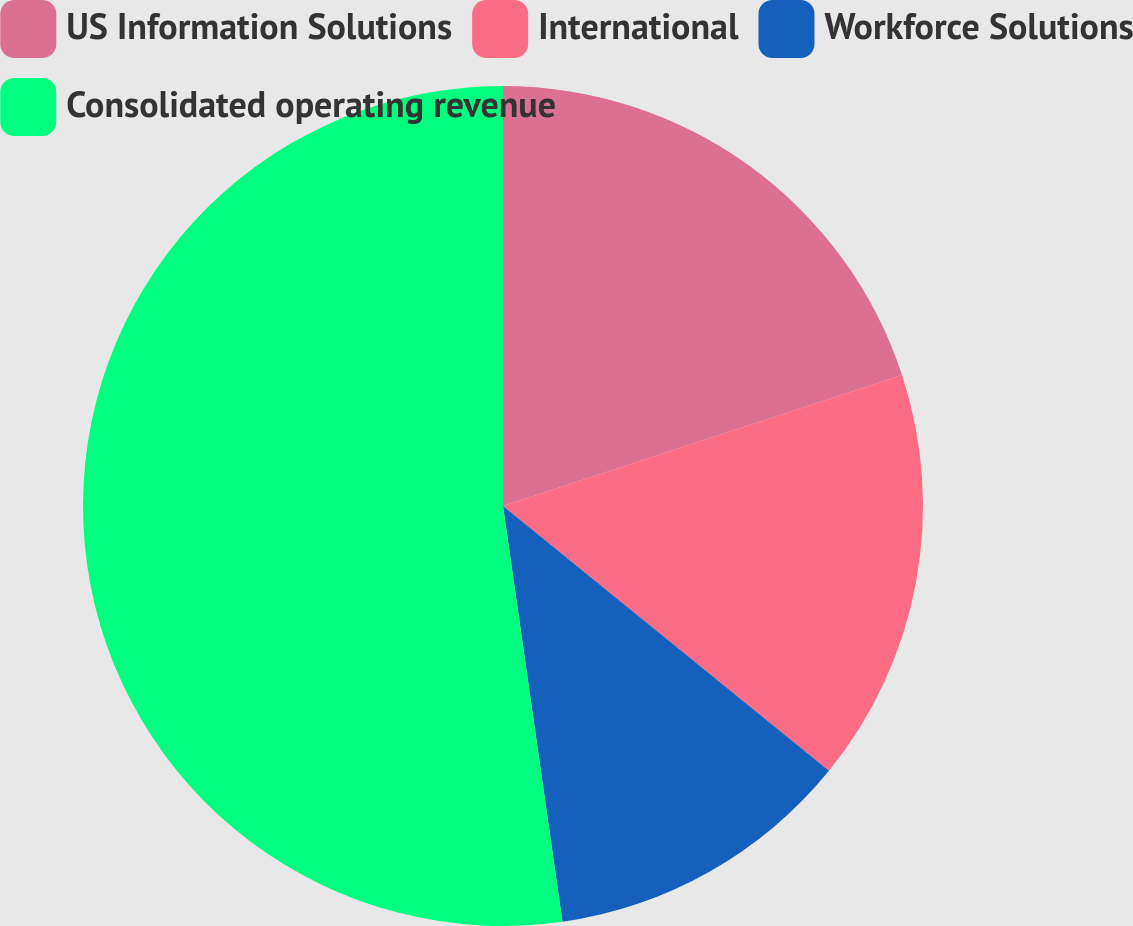<chart> <loc_0><loc_0><loc_500><loc_500><pie_chart><fcel>US Information Solutions<fcel>International<fcel>Workforce Solutions<fcel>Consolidated operating revenue<nl><fcel>19.95%<fcel>15.91%<fcel>11.88%<fcel>52.26%<nl></chart> 